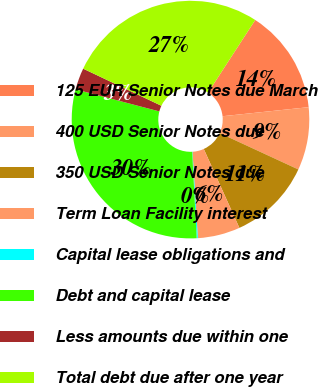Convert chart to OTSL. <chart><loc_0><loc_0><loc_500><loc_500><pie_chart><fcel>125 EUR Senior Notes due March<fcel>400 USD Senior Notes due<fcel>350 USD Senior Notes due<fcel>Term Loan Facility interest<fcel>Capital lease obligations and<fcel>Debt and capital lease<fcel>Less amounts due within one<fcel>Total debt due after one year<nl><fcel>14.16%<fcel>8.56%<fcel>11.36%<fcel>5.76%<fcel>0.16%<fcel>29.92%<fcel>2.96%<fcel>27.12%<nl></chart> 